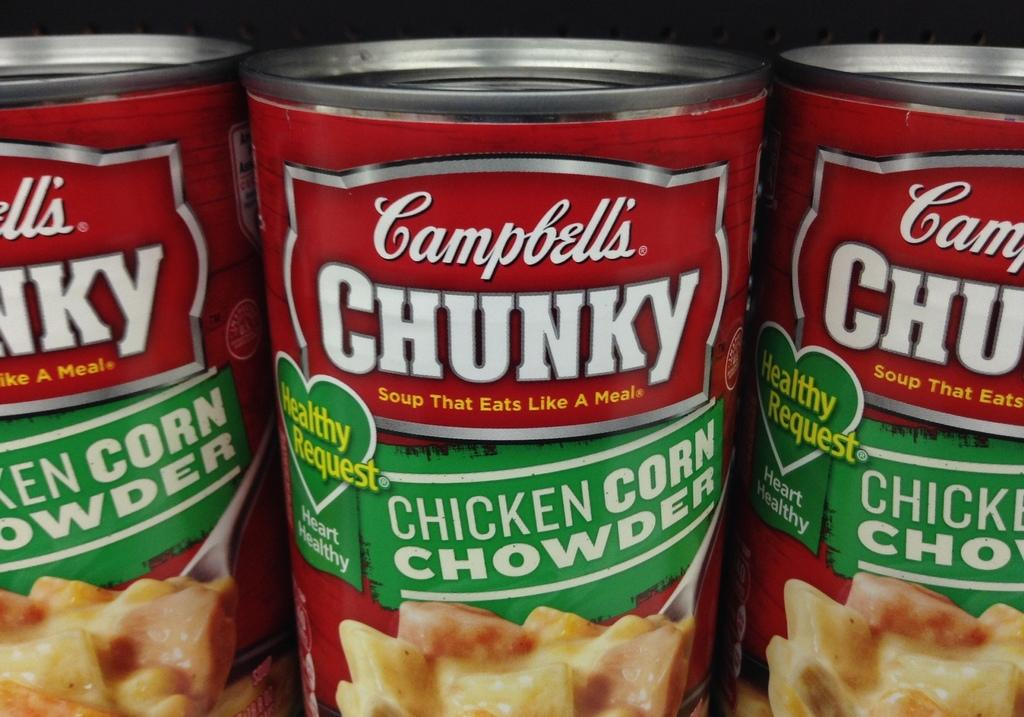What color are the tins in the image? The tins in the image are red. How many tins are there in the image? There are three tins in the image. Where are the tins located in the image? The tins are in the middle of the image. What can be found on the tins? There is text on the tins. What type of wine is being served in the image? There is no wine or any indication of a serving activity in the image; it only features three red color tins with text on them. 